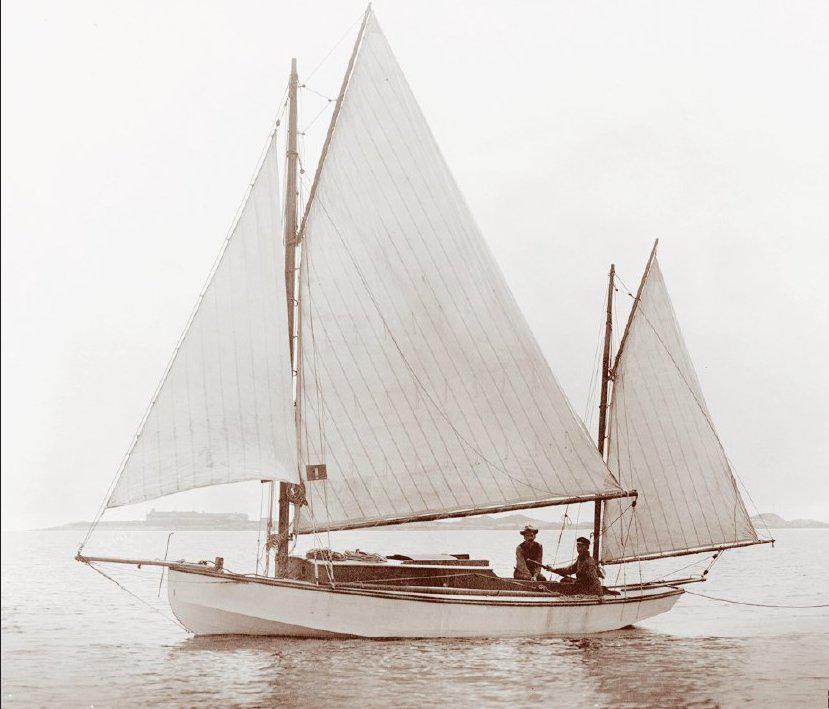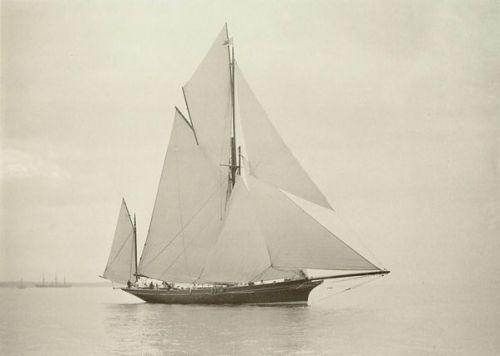The first image is the image on the left, the second image is the image on the right. Analyze the images presented: Is the assertion "A few clouds are visible in the picture on the left." valid? Answer yes or no. No. The first image is the image on the left, the second image is the image on the right. Assess this claim about the two images: "An image shows a boat with white sails in a body of blue water.". Correct or not? Answer yes or no. No. 